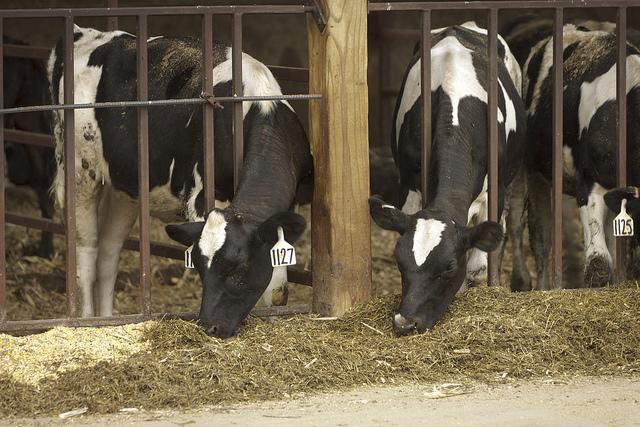What color are the cows? The cows have distinct black and white patches on their bodies. 